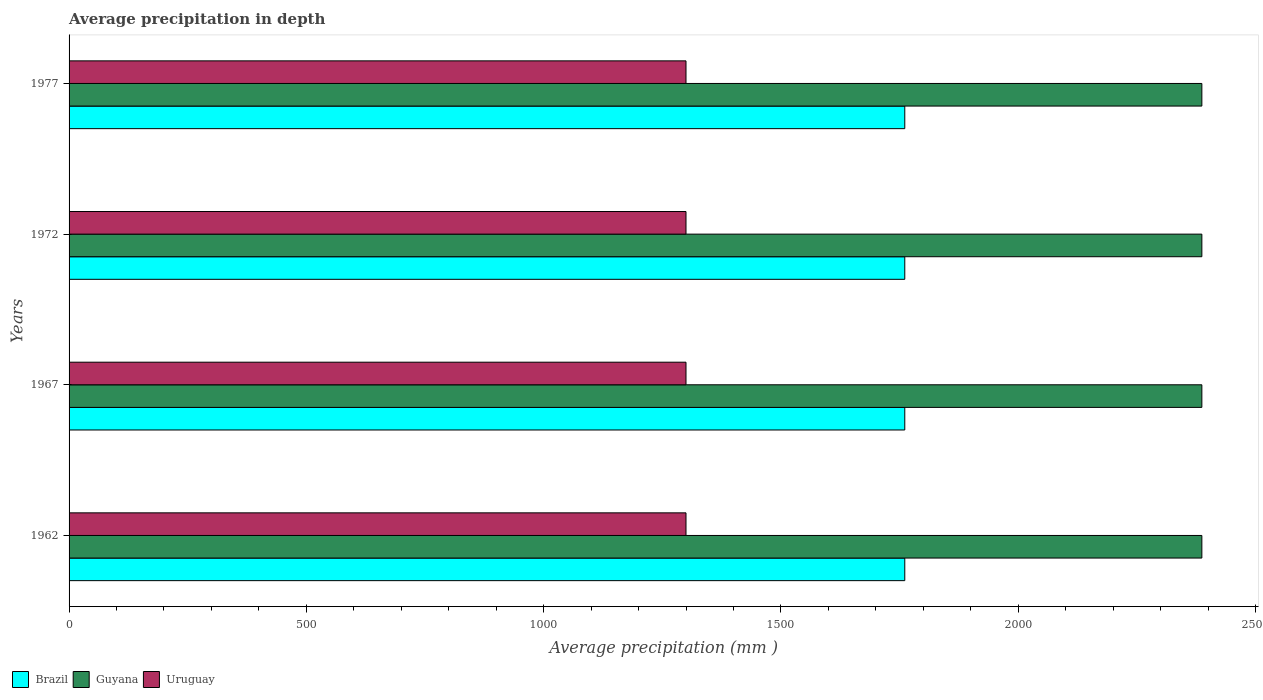How many different coloured bars are there?
Ensure brevity in your answer.  3. How many groups of bars are there?
Keep it short and to the point. 4. Are the number of bars per tick equal to the number of legend labels?
Your answer should be very brief. Yes. Are the number of bars on each tick of the Y-axis equal?
Keep it short and to the point. Yes. In how many cases, is the number of bars for a given year not equal to the number of legend labels?
Your answer should be compact. 0. What is the average precipitation in Uruguay in 1967?
Keep it short and to the point. 1300. Across all years, what is the maximum average precipitation in Brazil?
Offer a terse response. 1761. Across all years, what is the minimum average precipitation in Guyana?
Provide a short and direct response. 2387. In which year was the average precipitation in Uruguay maximum?
Offer a terse response. 1962. What is the total average precipitation in Uruguay in the graph?
Provide a succinct answer. 5200. What is the difference between the average precipitation in Uruguay in 1967 and that in 1972?
Offer a very short reply. 0. What is the difference between the average precipitation in Brazil in 1962 and the average precipitation in Uruguay in 1972?
Your answer should be compact. 461. What is the average average precipitation in Guyana per year?
Your response must be concise. 2387. In the year 1972, what is the difference between the average precipitation in Uruguay and average precipitation in Brazil?
Offer a very short reply. -461. What is the ratio of the average precipitation in Brazil in 1972 to that in 1977?
Give a very brief answer. 1. Is the average precipitation in Uruguay in 1962 less than that in 1972?
Give a very brief answer. No. Is the sum of the average precipitation in Uruguay in 1967 and 1977 greater than the maximum average precipitation in Guyana across all years?
Your response must be concise. Yes. What does the 2nd bar from the top in 1972 represents?
Your answer should be very brief. Guyana. What does the 2nd bar from the bottom in 1962 represents?
Your response must be concise. Guyana. How many bars are there?
Offer a very short reply. 12. Are all the bars in the graph horizontal?
Keep it short and to the point. Yes. How many years are there in the graph?
Your answer should be compact. 4. Are the values on the major ticks of X-axis written in scientific E-notation?
Make the answer very short. No. Does the graph contain grids?
Your response must be concise. No. What is the title of the graph?
Offer a terse response. Average precipitation in depth. What is the label or title of the X-axis?
Provide a succinct answer. Average precipitation (mm ). What is the label or title of the Y-axis?
Your answer should be compact. Years. What is the Average precipitation (mm ) in Brazil in 1962?
Make the answer very short. 1761. What is the Average precipitation (mm ) in Guyana in 1962?
Give a very brief answer. 2387. What is the Average precipitation (mm ) of Uruguay in 1962?
Your answer should be compact. 1300. What is the Average precipitation (mm ) of Brazil in 1967?
Make the answer very short. 1761. What is the Average precipitation (mm ) of Guyana in 1967?
Provide a short and direct response. 2387. What is the Average precipitation (mm ) in Uruguay in 1967?
Your answer should be compact. 1300. What is the Average precipitation (mm ) in Brazil in 1972?
Give a very brief answer. 1761. What is the Average precipitation (mm ) of Guyana in 1972?
Offer a very short reply. 2387. What is the Average precipitation (mm ) in Uruguay in 1972?
Offer a terse response. 1300. What is the Average precipitation (mm ) of Brazil in 1977?
Your response must be concise. 1761. What is the Average precipitation (mm ) in Guyana in 1977?
Keep it short and to the point. 2387. What is the Average precipitation (mm ) of Uruguay in 1977?
Your answer should be very brief. 1300. Across all years, what is the maximum Average precipitation (mm ) in Brazil?
Your answer should be compact. 1761. Across all years, what is the maximum Average precipitation (mm ) of Guyana?
Offer a very short reply. 2387. Across all years, what is the maximum Average precipitation (mm ) of Uruguay?
Offer a terse response. 1300. Across all years, what is the minimum Average precipitation (mm ) of Brazil?
Make the answer very short. 1761. Across all years, what is the minimum Average precipitation (mm ) of Guyana?
Provide a short and direct response. 2387. Across all years, what is the minimum Average precipitation (mm ) of Uruguay?
Provide a succinct answer. 1300. What is the total Average precipitation (mm ) of Brazil in the graph?
Give a very brief answer. 7044. What is the total Average precipitation (mm ) in Guyana in the graph?
Offer a very short reply. 9548. What is the total Average precipitation (mm ) of Uruguay in the graph?
Ensure brevity in your answer.  5200. What is the difference between the Average precipitation (mm ) of Brazil in 1962 and that in 1972?
Provide a short and direct response. 0. What is the difference between the Average precipitation (mm ) of Guyana in 1962 and that in 1972?
Provide a succinct answer. 0. What is the difference between the Average precipitation (mm ) in Brazil in 1962 and that in 1977?
Provide a short and direct response. 0. What is the difference between the Average precipitation (mm ) in Brazil in 1967 and that in 1977?
Your answer should be compact. 0. What is the difference between the Average precipitation (mm ) of Uruguay in 1967 and that in 1977?
Your response must be concise. 0. What is the difference between the Average precipitation (mm ) in Guyana in 1972 and that in 1977?
Offer a terse response. 0. What is the difference between the Average precipitation (mm ) of Brazil in 1962 and the Average precipitation (mm ) of Guyana in 1967?
Offer a very short reply. -626. What is the difference between the Average precipitation (mm ) in Brazil in 1962 and the Average precipitation (mm ) in Uruguay in 1967?
Provide a succinct answer. 461. What is the difference between the Average precipitation (mm ) in Guyana in 1962 and the Average precipitation (mm ) in Uruguay in 1967?
Offer a very short reply. 1087. What is the difference between the Average precipitation (mm ) of Brazil in 1962 and the Average precipitation (mm ) of Guyana in 1972?
Keep it short and to the point. -626. What is the difference between the Average precipitation (mm ) in Brazil in 1962 and the Average precipitation (mm ) in Uruguay in 1972?
Provide a succinct answer. 461. What is the difference between the Average precipitation (mm ) in Guyana in 1962 and the Average precipitation (mm ) in Uruguay in 1972?
Ensure brevity in your answer.  1087. What is the difference between the Average precipitation (mm ) in Brazil in 1962 and the Average precipitation (mm ) in Guyana in 1977?
Provide a succinct answer. -626. What is the difference between the Average precipitation (mm ) of Brazil in 1962 and the Average precipitation (mm ) of Uruguay in 1977?
Keep it short and to the point. 461. What is the difference between the Average precipitation (mm ) in Guyana in 1962 and the Average precipitation (mm ) in Uruguay in 1977?
Your answer should be compact. 1087. What is the difference between the Average precipitation (mm ) of Brazil in 1967 and the Average precipitation (mm ) of Guyana in 1972?
Provide a succinct answer. -626. What is the difference between the Average precipitation (mm ) of Brazil in 1967 and the Average precipitation (mm ) of Uruguay in 1972?
Your response must be concise. 461. What is the difference between the Average precipitation (mm ) in Guyana in 1967 and the Average precipitation (mm ) in Uruguay in 1972?
Provide a succinct answer. 1087. What is the difference between the Average precipitation (mm ) in Brazil in 1967 and the Average precipitation (mm ) in Guyana in 1977?
Keep it short and to the point. -626. What is the difference between the Average precipitation (mm ) in Brazil in 1967 and the Average precipitation (mm ) in Uruguay in 1977?
Make the answer very short. 461. What is the difference between the Average precipitation (mm ) of Guyana in 1967 and the Average precipitation (mm ) of Uruguay in 1977?
Ensure brevity in your answer.  1087. What is the difference between the Average precipitation (mm ) of Brazil in 1972 and the Average precipitation (mm ) of Guyana in 1977?
Your answer should be compact. -626. What is the difference between the Average precipitation (mm ) of Brazil in 1972 and the Average precipitation (mm ) of Uruguay in 1977?
Keep it short and to the point. 461. What is the difference between the Average precipitation (mm ) in Guyana in 1972 and the Average precipitation (mm ) in Uruguay in 1977?
Provide a succinct answer. 1087. What is the average Average precipitation (mm ) of Brazil per year?
Your response must be concise. 1761. What is the average Average precipitation (mm ) in Guyana per year?
Provide a short and direct response. 2387. What is the average Average precipitation (mm ) in Uruguay per year?
Keep it short and to the point. 1300. In the year 1962, what is the difference between the Average precipitation (mm ) in Brazil and Average precipitation (mm ) in Guyana?
Offer a terse response. -626. In the year 1962, what is the difference between the Average precipitation (mm ) of Brazil and Average precipitation (mm ) of Uruguay?
Your answer should be very brief. 461. In the year 1962, what is the difference between the Average precipitation (mm ) in Guyana and Average precipitation (mm ) in Uruguay?
Offer a terse response. 1087. In the year 1967, what is the difference between the Average precipitation (mm ) of Brazil and Average precipitation (mm ) of Guyana?
Your answer should be very brief. -626. In the year 1967, what is the difference between the Average precipitation (mm ) of Brazil and Average precipitation (mm ) of Uruguay?
Give a very brief answer. 461. In the year 1967, what is the difference between the Average precipitation (mm ) of Guyana and Average precipitation (mm ) of Uruguay?
Your response must be concise. 1087. In the year 1972, what is the difference between the Average precipitation (mm ) of Brazil and Average precipitation (mm ) of Guyana?
Keep it short and to the point. -626. In the year 1972, what is the difference between the Average precipitation (mm ) in Brazil and Average precipitation (mm ) in Uruguay?
Give a very brief answer. 461. In the year 1972, what is the difference between the Average precipitation (mm ) of Guyana and Average precipitation (mm ) of Uruguay?
Keep it short and to the point. 1087. In the year 1977, what is the difference between the Average precipitation (mm ) of Brazil and Average precipitation (mm ) of Guyana?
Offer a terse response. -626. In the year 1977, what is the difference between the Average precipitation (mm ) of Brazil and Average precipitation (mm ) of Uruguay?
Offer a very short reply. 461. In the year 1977, what is the difference between the Average precipitation (mm ) of Guyana and Average precipitation (mm ) of Uruguay?
Give a very brief answer. 1087. What is the ratio of the Average precipitation (mm ) in Brazil in 1962 to that in 1967?
Ensure brevity in your answer.  1. What is the ratio of the Average precipitation (mm ) of Guyana in 1962 to that in 1967?
Your answer should be compact. 1. What is the ratio of the Average precipitation (mm ) in Brazil in 1962 to that in 1977?
Make the answer very short. 1. What is the ratio of the Average precipitation (mm ) in Guyana in 1962 to that in 1977?
Ensure brevity in your answer.  1. What is the ratio of the Average precipitation (mm ) in Uruguay in 1962 to that in 1977?
Your response must be concise. 1. What is the ratio of the Average precipitation (mm ) in Uruguay in 1967 to that in 1972?
Give a very brief answer. 1. What is the ratio of the Average precipitation (mm ) of Uruguay in 1967 to that in 1977?
Your answer should be compact. 1. What is the ratio of the Average precipitation (mm ) of Uruguay in 1972 to that in 1977?
Make the answer very short. 1. What is the difference between the highest and the second highest Average precipitation (mm ) of Brazil?
Your answer should be compact. 0. What is the difference between the highest and the lowest Average precipitation (mm ) in Brazil?
Your response must be concise. 0. 